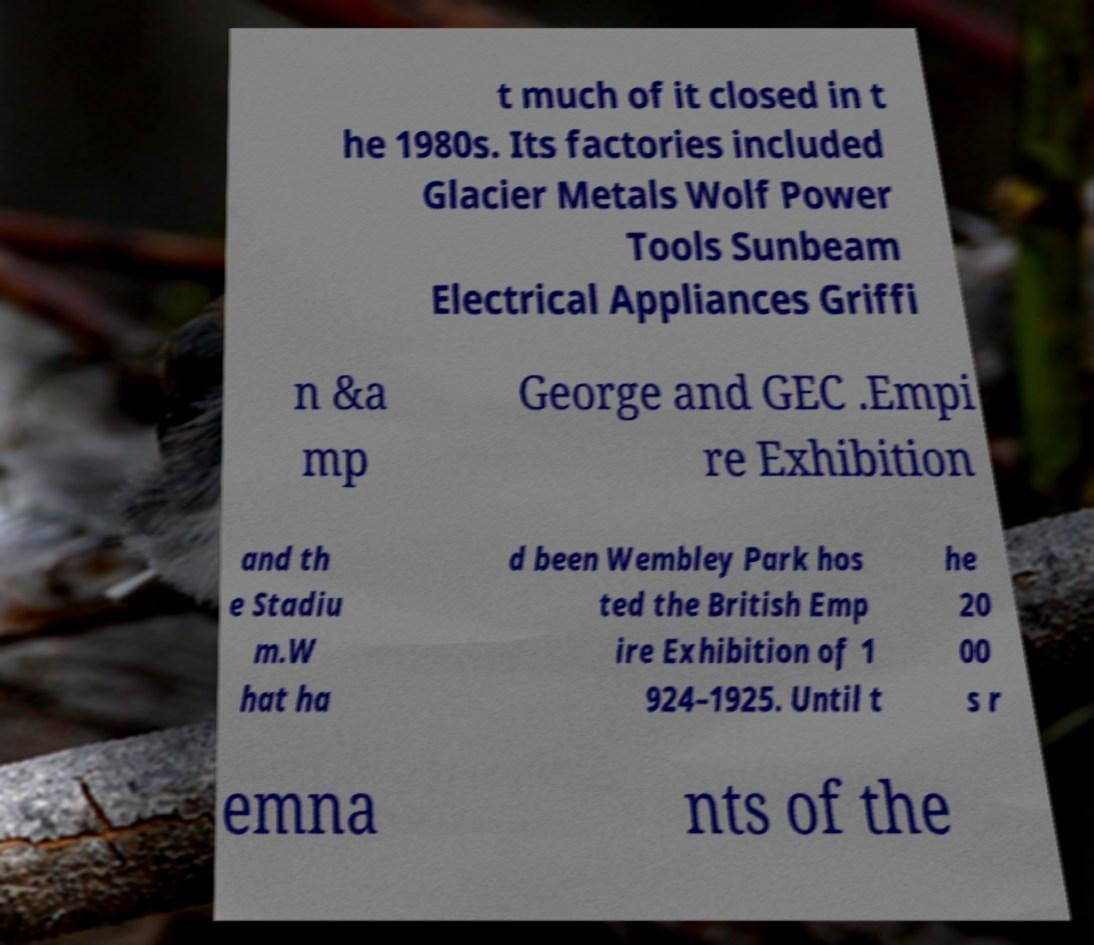Could you extract and type out the text from this image? t much of it closed in t he 1980s. Its factories included Glacier Metals Wolf Power Tools Sunbeam Electrical Appliances Griffi n &a mp George and GEC .Empi re Exhibition and th e Stadiu m.W hat ha d been Wembley Park hos ted the British Emp ire Exhibition of 1 924–1925. Until t he 20 00 s r emna nts of the 